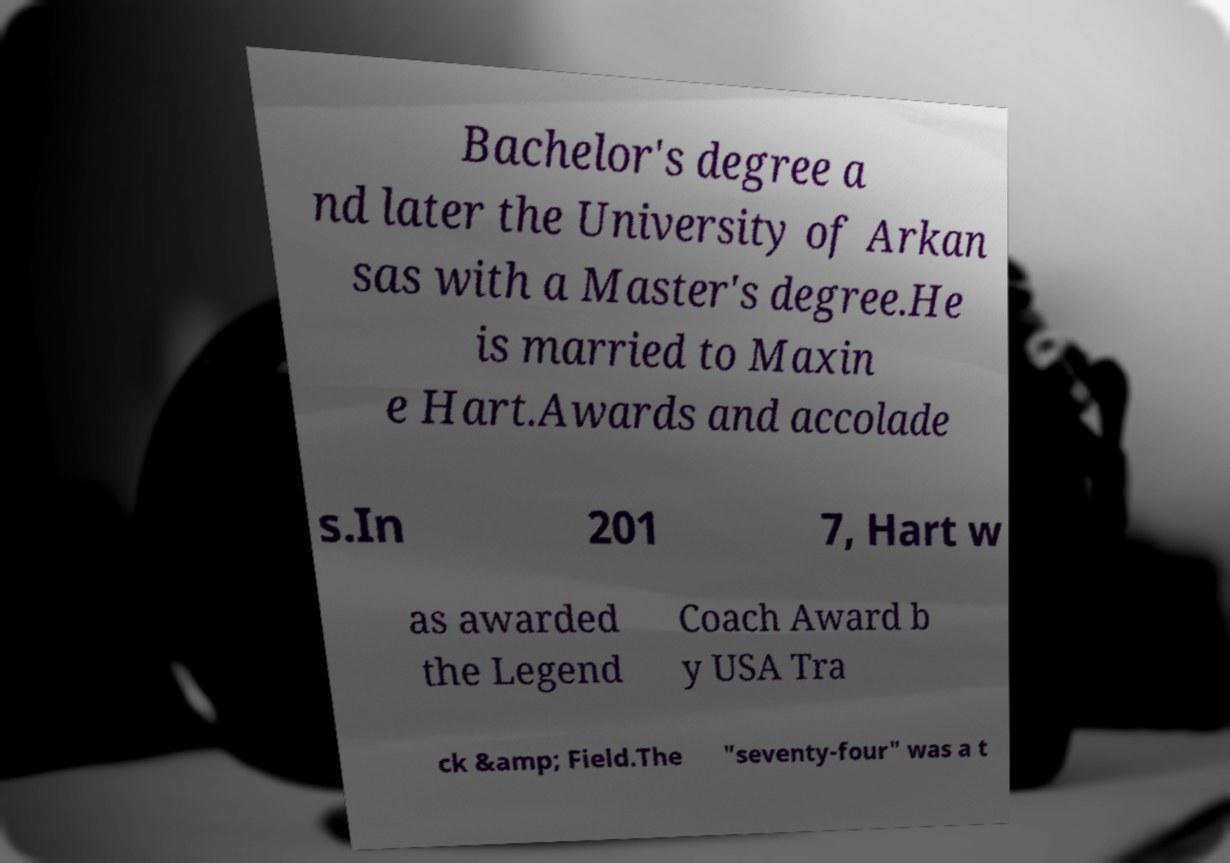Can you accurately transcribe the text from the provided image for me? Bachelor's degree a nd later the University of Arkan sas with a Master's degree.He is married to Maxin e Hart.Awards and accolade s.In 201 7, Hart w as awarded the Legend Coach Award b y USA Tra ck &amp; Field.The "seventy-four" was a t 